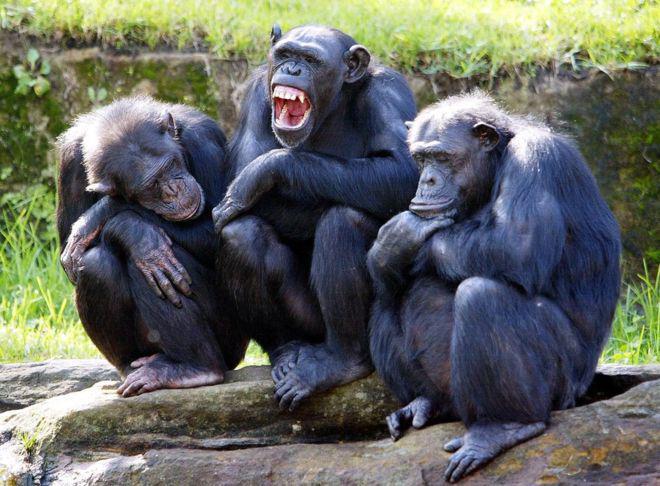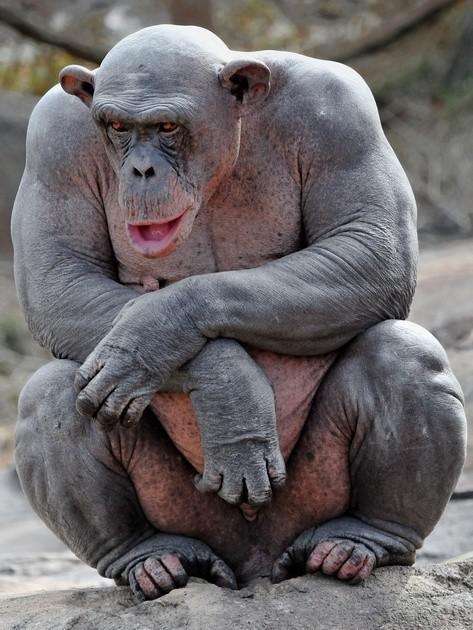The first image is the image on the left, the second image is the image on the right. For the images displayed, is the sentence "An image shows one squatting ape, which is hairless." factually correct? Answer yes or no. Yes. The first image is the image on the left, the second image is the image on the right. Considering the images on both sides, is "There is a single hairless chimp in the right image." valid? Answer yes or no. Yes. 